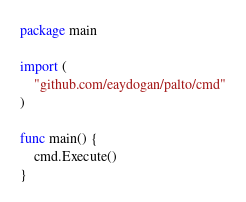<code> <loc_0><loc_0><loc_500><loc_500><_Go_>package main

import (
	"github.com/eaydogan/palto/cmd"
)

func main() {
	cmd.Execute()
}
</code> 